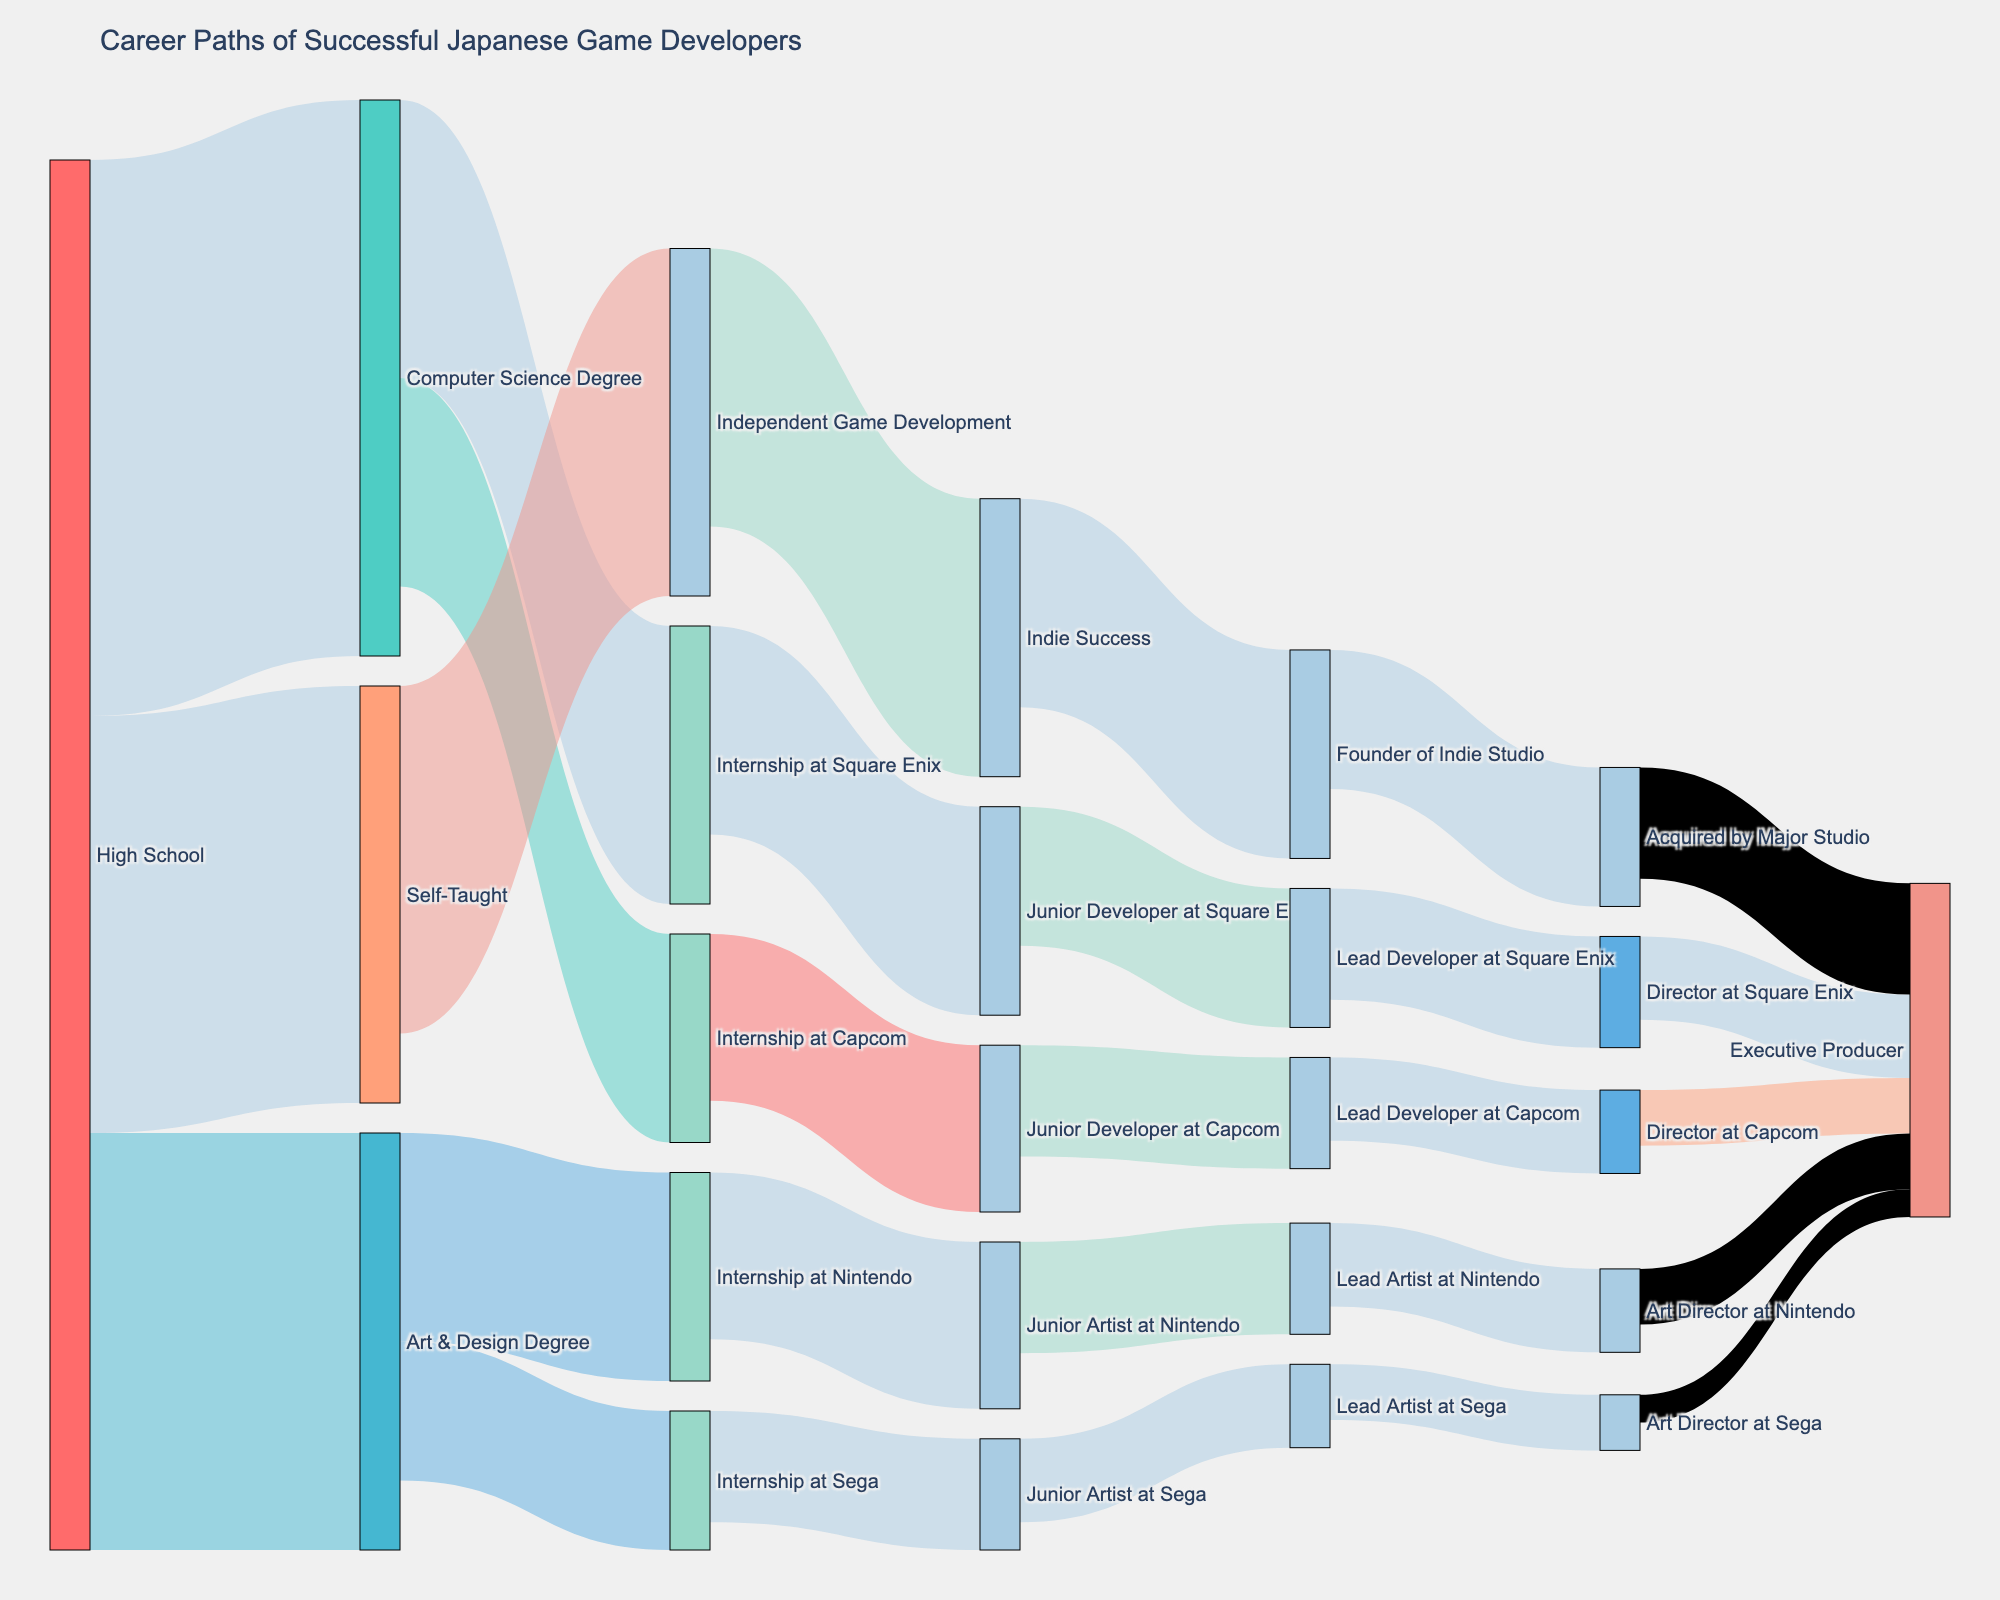What is the title of the figure? The title is usually displayed prominently at the top of the figure. In this case, it should be mentioned in the layout settings of the visualization.
Answer: Career Paths of Successful Japanese Game Developers What is the color for "High School"? The color for "High School" is set in the color dictionary. Look at the relevant label color in the figure according to the color dictionary.
Answer: #FF6B6B (a pinkish red shade) Which career path results in the most "Lead Developer" positions at Capcom? Follow the paths from various sources to the destination. Identify the source that feeds the most into the role "Lead Developer at Capcom".
Answer: Junior Developer at Capcom How many individuals moved directly from "High School" to "Self-Taught"? Trace the path starting from "High School" and see how many head towards "Self-Taught" directly, referencing the value in the link.
Answer: 30 What is the initial step most individuals take towards a career in game development? Find the highest value originating from "High School." This value will indicate the most common initial step.
Answer: Computer Science Degree Compare the number of individuals reaching "Executive Producer" by moving through a "Computer Science Degree" versus those who are "Self-Taught". Add up the individuals who reach "Executive Producer" from paths that start with "Computer Science Degree" and compare to those from "Self-Taught".
Answer: Computer Science Degree: 6 (from Square Enix) + 4 (from Capcom) + 4 (from Nintendo) + 2 (from Sega) = 16, Self-Taught: 8 (through Indie Studio) What is the total number of individuals who held an "Internship" position at any company? Sum up the values for each internship position based on their direct entry from education paths.
Answer: 60 (20+15 from Computer Science; 15+10 from Art & Design) How many people advancing from "Lead Developer" to "Director" at Square Enix? Trace the path specifically from "Lead Developer at Square Enix" to "Director at Square Enix" and note the value.
Answer: 8 Which path shows the highest number of individuals achieving "Indie Success"? Look for the largest value associated with paths leading to "Indie Success," typically marked by outgoing links from "Independent Game Development."
Answer: Independent Game Development has a value of 20 leading to Indie Success 